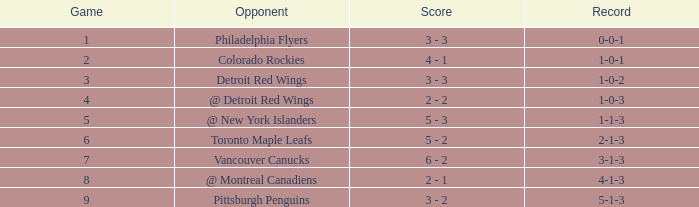Identify the smallest game for october 2 5.0. 